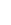Convert formula to latex. <formula><loc_0><loc_0><loc_500><loc_500>\begin{matrix} \\ \\ \end{matrix}</formula> 